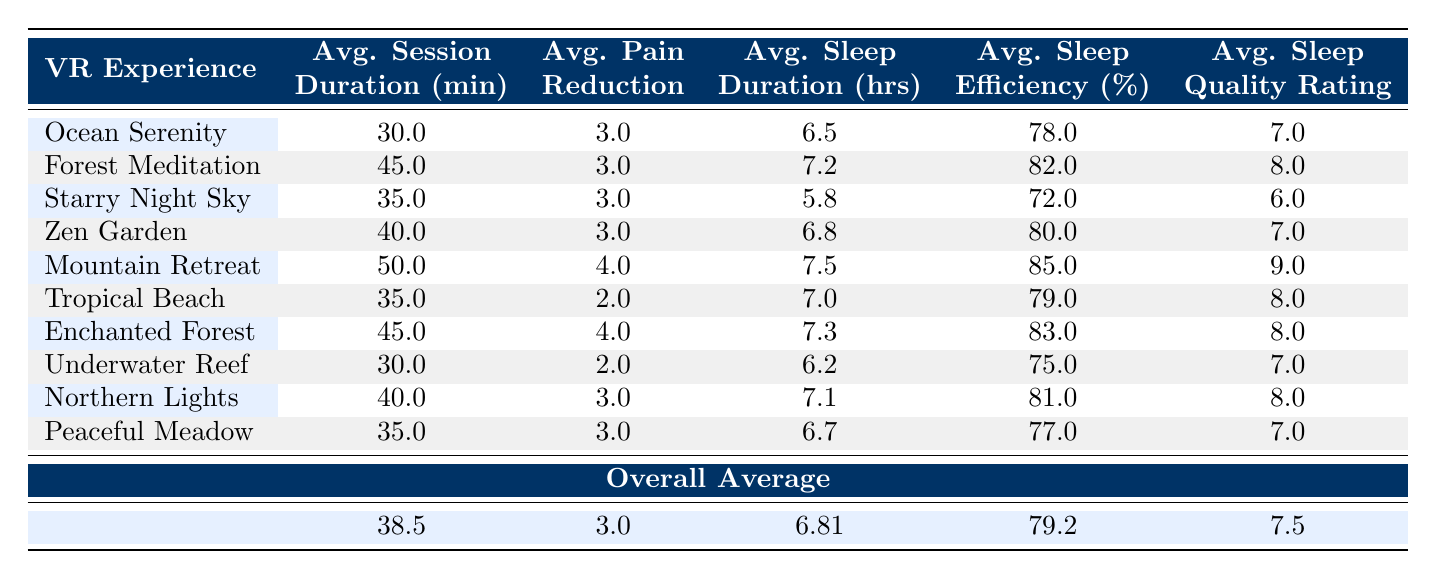What is the average session duration for the "Mountain Retreat" experience? By looking at the table, we see that the session duration for "Mountain Retreat" is listed as 50 minutes. This is a direct retrieval of the value from the table.
Answer: 50 minutes Which VR experience has the highest sleep quality rating? The table shows sleep quality ratings for each VR experience. "Mountain Retreat" has the highest rating at 9, compared to the other experiences.
Answer: Mountain Retreat What is the average pain reduction across all VR experiences? To calculate the average pain reduction, add all the pain reductions (3 + 3 + 3 + 3 + 4 + 2 + 4 + 2 + 3 + 3 = 30) and then divide by the number of experiences (10). The average is 30/10 = 3.
Answer: 3 Did "Underwater Reef" experience result in a higher average sleep efficiency than "Starry Night Sky"? From the table, "Underwater Reef" has an efficiency of 75%, while "Starry Night Sky" has 72%. Comparing these two values, Underwater Reef (75%) is indeed higher than Starry Night Sky (72%).
Answer: Yes What is the average sleep duration for all experiences? To find the average sleep duration, sum the sleep durations (6.5 + 7.2 + 5.8 + 6.8 + 7.5 + 7.0 + 7.3 + 6.2 + 7.1 + 6.7 = 68.1) and divide by the number of experiences (10). The average sleep duration is 68.1/10 = 6.81 hours.
Answer: 6.81 hours Which session had the lowest pain level after the VR experience? Referring to the table values for post-session pain levels, "Mountain Retreat" leads with a post-session pain level of 2, which is the lowest when comparing all experiences.
Answer: Mountain Retreat Is the average sleep efficiency higher than 80% across all experiences? The overall average sleep efficiency from the table is 79.2%. Since 79.2% is lower than 80%, the answer is no.
Answer: No What is the difference in deep sleep minutes between "Mountain Retreat" and "Starry Night Sky"? For "Mountain Retreat," deep sleep minutes is 120, and for "Starry Night Sky," it is 75. The difference can be calculated by subtracting the lower value from the higher one (120 - 75 = 45).
Answer: 45 minutes How many experiences have a sleep quality rating of 8 or higher? By checking the sleep quality ratings in the table, "Forest Meditation," "Mountain Retreat," "Tropical Beach," "Enchanted Forest," and "Northern Lights" all have ratings of 8 or higher. Counting these gives us a total of 5 experiences.
Answer: 5 